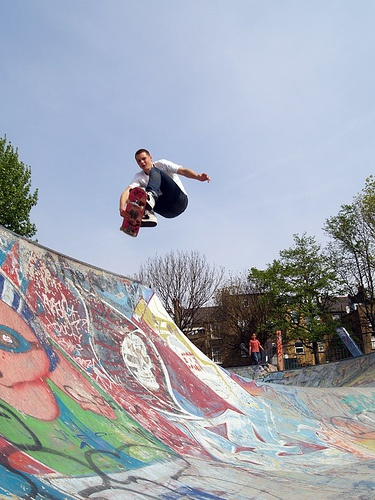Describe the objects in this image and their specific colors. I can see people in darkgray, black, white, gray, and maroon tones, skateboard in darkgray, maroon, black, and brown tones, and people in darkgray, black, maroon, brown, and salmon tones in this image. 